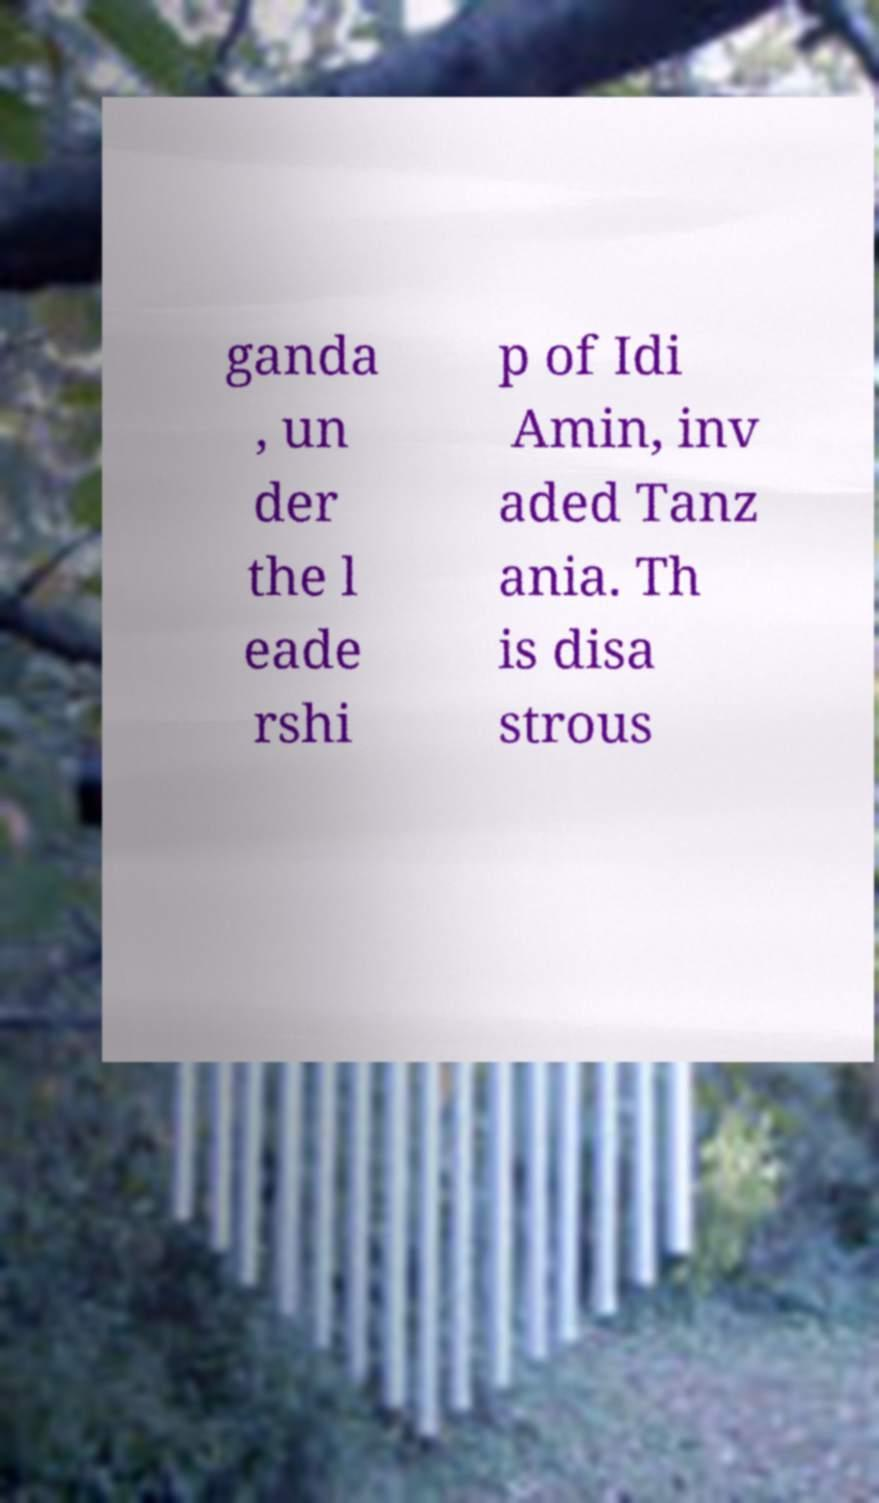For documentation purposes, I need the text within this image transcribed. Could you provide that? ganda , un der the l eade rshi p of Idi Amin, inv aded Tanz ania. Th is disa strous 